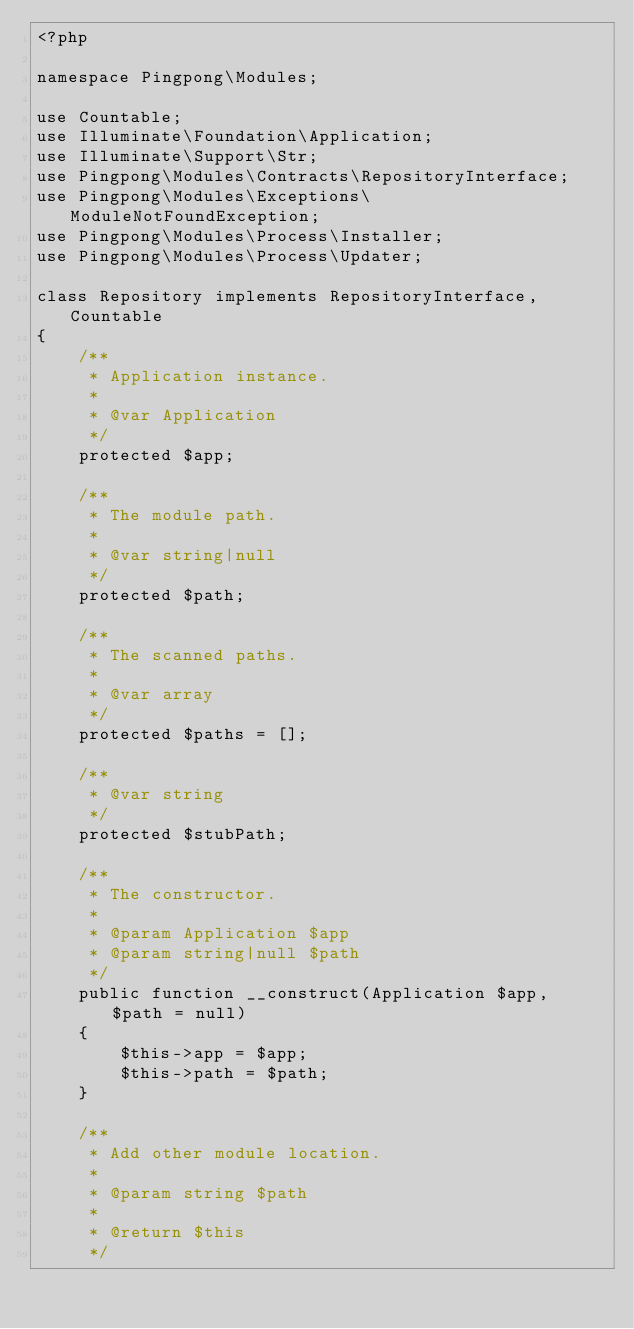<code> <loc_0><loc_0><loc_500><loc_500><_PHP_><?php

namespace Pingpong\Modules;

use Countable;
use Illuminate\Foundation\Application;
use Illuminate\Support\Str;
use Pingpong\Modules\Contracts\RepositoryInterface;
use Pingpong\Modules\Exceptions\ModuleNotFoundException;
use Pingpong\Modules\Process\Installer;
use Pingpong\Modules\Process\Updater;

class Repository implements RepositoryInterface, Countable
{
    /**
     * Application instance.
     *
     * @var Application
     */
    protected $app;

    /**
     * The module path.
     *
     * @var string|null
     */
    protected $path;

    /**
     * The scanned paths.
     *
     * @var array
     */
    protected $paths = [];

    /**
     * @var string
     */
    protected $stubPath;

    /**
     * The constructor.
     *
     * @param Application $app
     * @param string|null $path
     */
    public function __construct(Application $app, $path = null)
    {
        $this->app = $app;
        $this->path = $path;
    }

    /**
     * Add other module location.
     *
     * @param string $path
     *
     * @return $this
     */</code> 